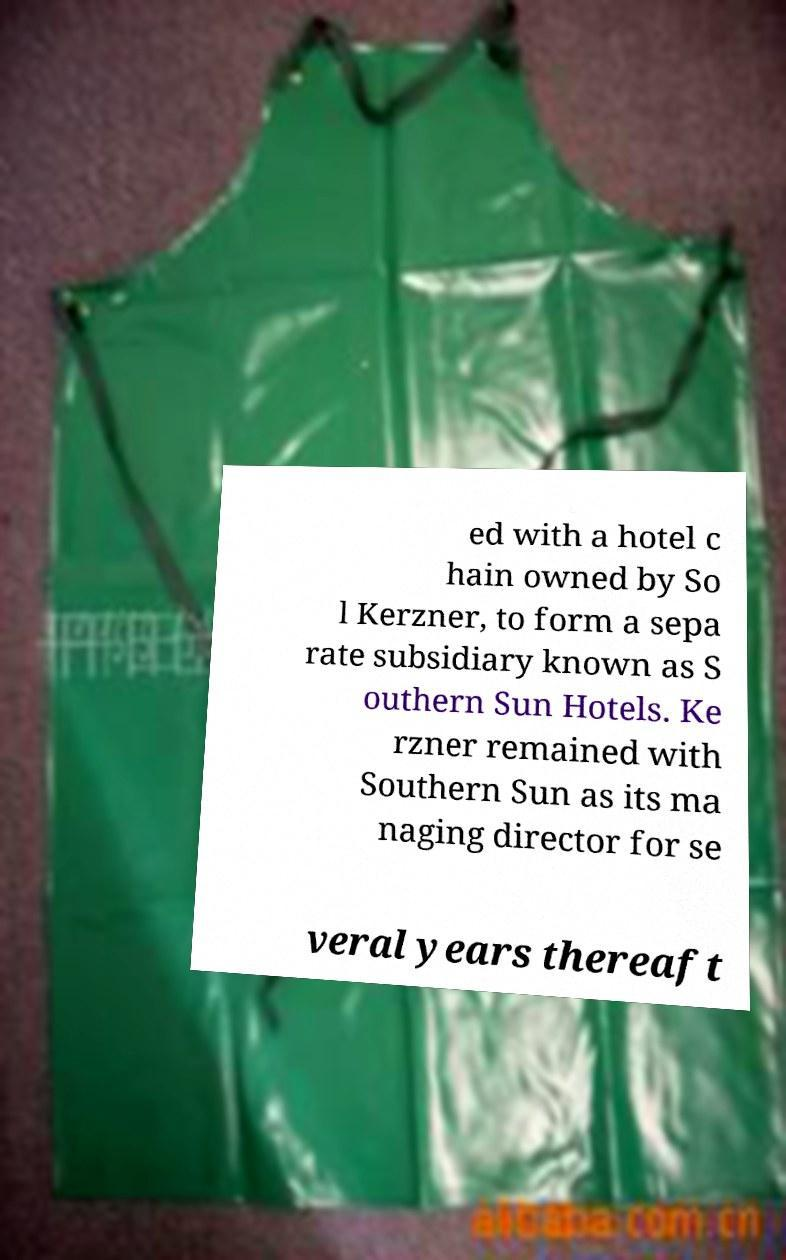For documentation purposes, I need the text within this image transcribed. Could you provide that? ed with a hotel c hain owned by So l Kerzner, to form a sepa rate subsidiary known as S outhern Sun Hotels. Ke rzner remained with Southern Sun as its ma naging director for se veral years thereaft 